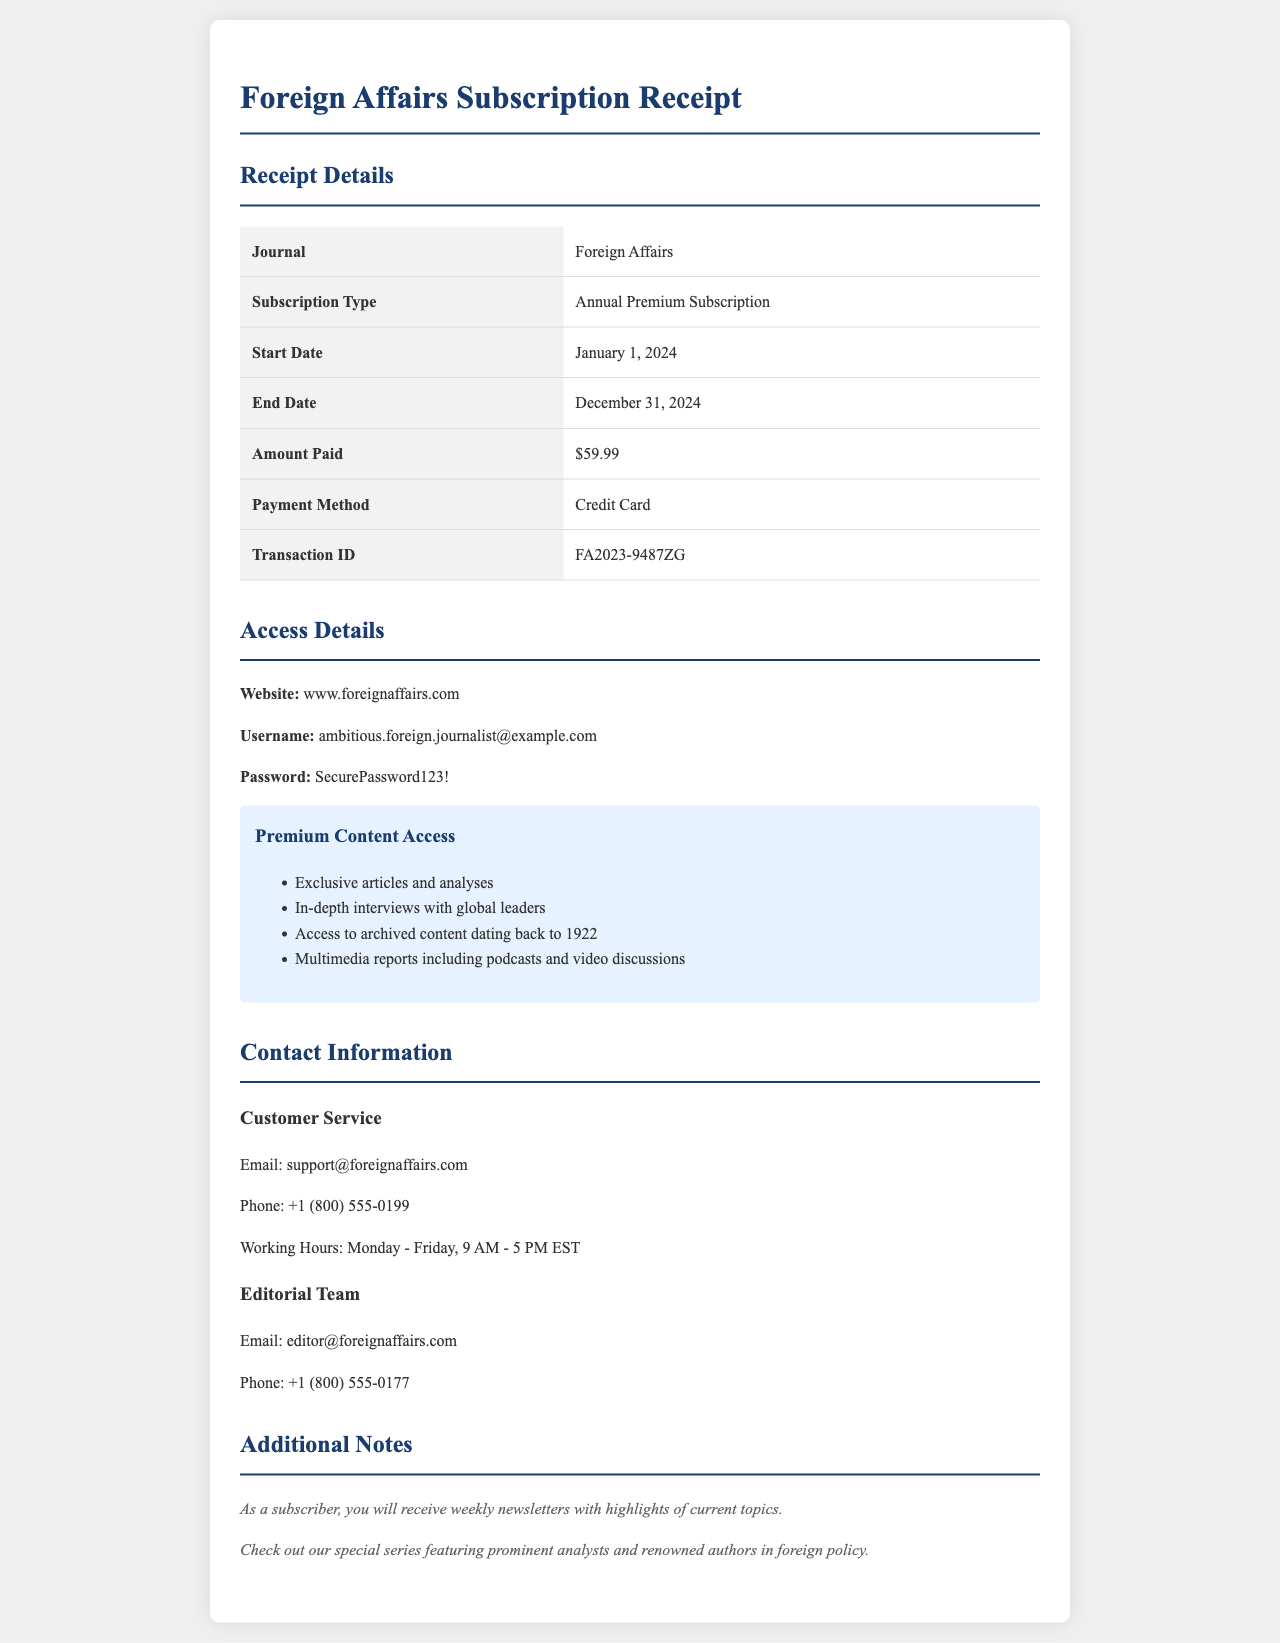What is the subscription type? The subscription type is identified in the document under "Subscription Type."
Answer: Annual Premium Subscription What is the amount paid? The amount paid is specified in the receipt under "Amount Paid."
Answer: $59.99 What is the start date of the subscription? The start date is mentioned in the receipt details as "Start Date."
Answer: January 1, 2024 What is the transaction ID? The transaction ID is found in the receipt section as "Transaction ID."
Answer: FA2023-9487ZG What type of content can subscribers access? The types of content available to premium subscribers are listed under "Premium Content Access."
Answer: Exclusive articles and analyses What email should customers use for support? The email for customer support is provided in the contact information section.
Answer: support@foreignaffairs.com What are the working hours for customer service? Working hours for customer service are specified in the contact information.
Answer: Monday - Friday, 9 AM - 5 PM EST How long does the subscription last? The subscription duration is indicated by the start and end dates given in the receipt.
Answer: 1 year What phone number can be used to contact the editorial team? The contact number for the editorial team is listed in the contact info section.
Answer: +1 (800) 555-0177 